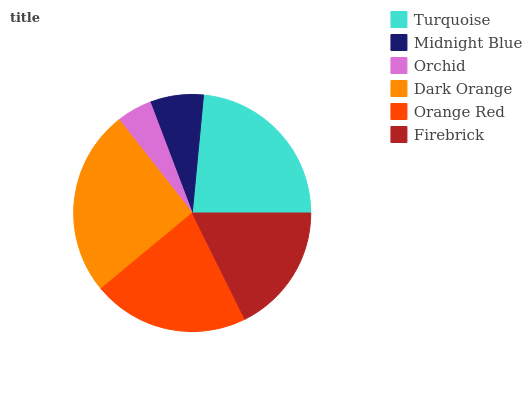Is Orchid the minimum?
Answer yes or no. Yes. Is Dark Orange the maximum?
Answer yes or no. Yes. Is Midnight Blue the minimum?
Answer yes or no. No. Is Midnight Blue the maximum?
Answer yes or no. No. Is Turquoise greater than Midnight Blue?
Answer yes or no. Yes. Is Midnight Blue less than Turquoise?
Answer yes or no. Yes. Is Midnight Blue greater than Turquoise?
Answer yes or no. No. Is Turquoise less than Midnight Blue?
Answer yes or no. No. Is Orange Red the high median?
Answer yes or no. Yes. Is Firebrick the low median?
Answer yes or no. Yes. Is Turquoise the high median?
Answer yes or no. No. Is Orchid the low median?
Answer yes or no. No. 